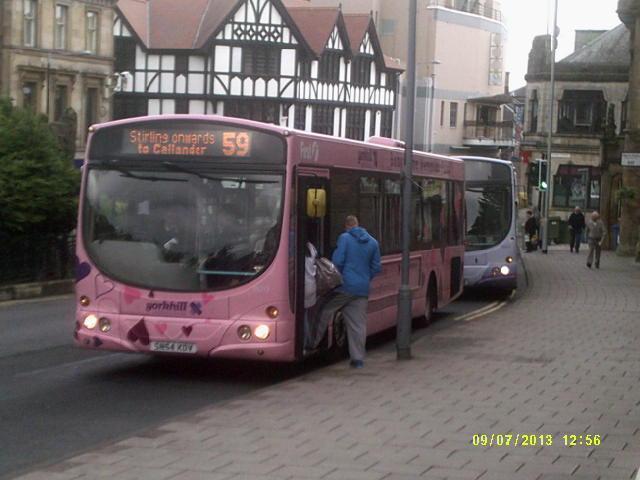How many people are boarding the bus?
Give a very brief answer. 2. How many buses can you see?
Give a very brief answer. 2. 